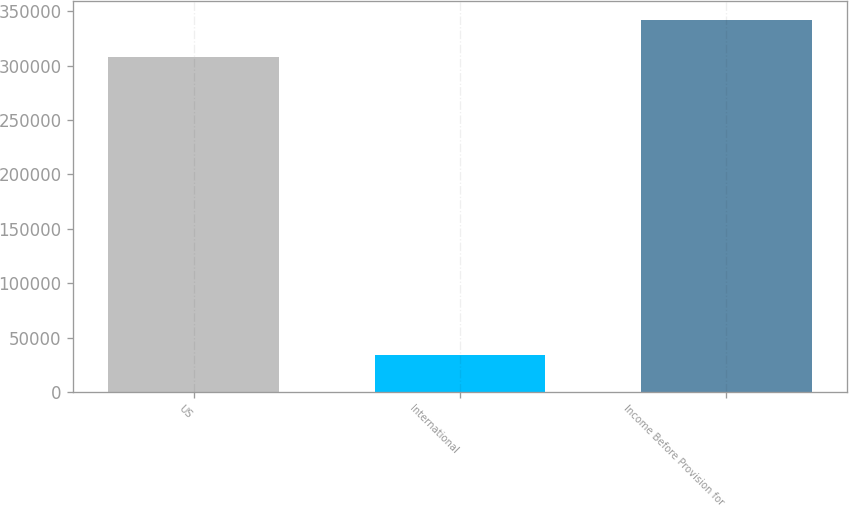Convert chart to OTSL. <chart><loc_0><loc_0><loc_500><loc_500><bar_chart><fcel>US<fcel>International<fcel>Income Before Provision for<nl><fcel>308003<fcel>34063<fcel>342066<nl></chart> 